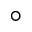<formula> <loc_0><loc_0><loc_500><loc_500>^ { \circ }</formula> 